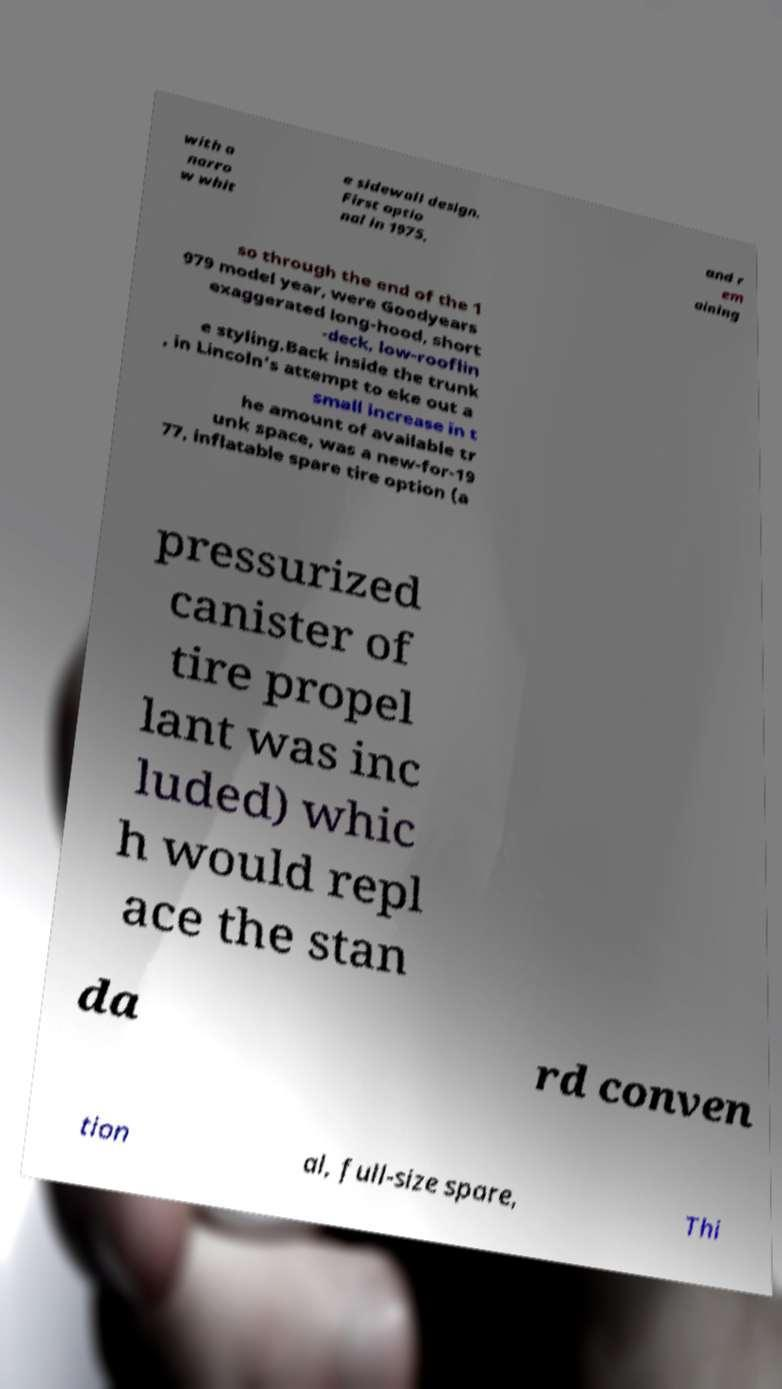I need the written content from this picture converted into text. Can you do that? with a narro w whit e sidewall design. First optio nal in 1975, and r em aining so through the end of the 1 979 model year, were Goodyears exaggerated long-hood, short -deck, low-rooflin e styling.Back inside the trunk , in Lincoln's attempt to eke out a small increase in t he amount of available tr unk space, was a new-for-19 77, inflatable spare tire option (a pressurized canister of tire propel lant was inc luded) whic h would repl ace the stan da rd conven tion al, full-size spare, Thi 